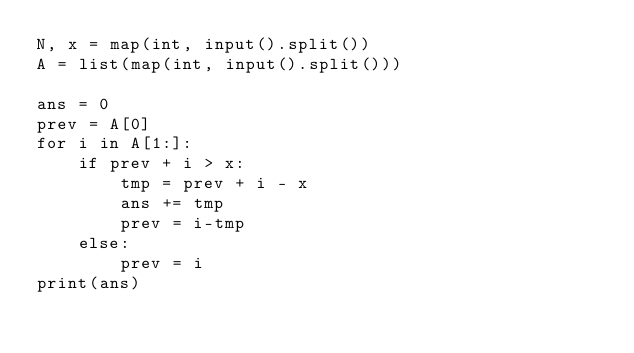<code> <loc_0><loc_0><loc_500><loc_500><_Python_>N, x = map(int, input().split())
A = list(map(int, input().split()))

ans = 0
prev = A[0]
for i in A[1:]:
    if prev + i > x:
        tmp = prev + i - x
        ans += tmp
        prev = i-tmp
    else:
        prev = i
print(ans)</code> 